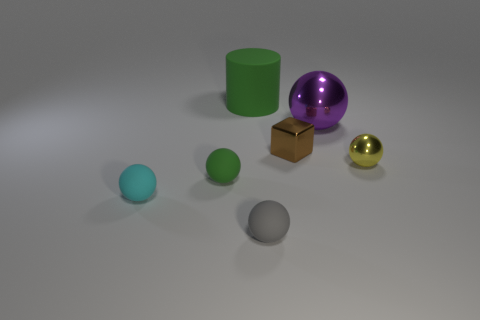Do the small rubber ball behind the cyan sphere and the large matte cylinder have the same color?
Ensure brevity in your answer.  Yes. What is the green thing that is behind the metal sphere that is behind the small object that is on the right side of the tiny metal cube made of?
Ensure brevity in your answer.  Rubber. Is the small gray ball made of the same material as the large green cylinder?
Ensure brevity in your answer.  Yes. What number of spheres are either purple things or tiny matte things?
Your answer should be very brief. 4. The large object that is right of the tiny gray thing is what color?
Give a very brief answer. Purple. What number of metal objects are small brown cylinders or small blocks?
Your response must be concise. 1. What is the material of the ball right of the big thing to the right of the small gray ball?
Provide a succinct answer. Metal. What color is the block?
Offer a terse response. Brown. There is a tiny ball on the right side of the purple shiny ball; is there a green thing behind it?
Your answer should be very brief. Yes. What is the large green object made of?
Your answer should be very brief. Rubber. 